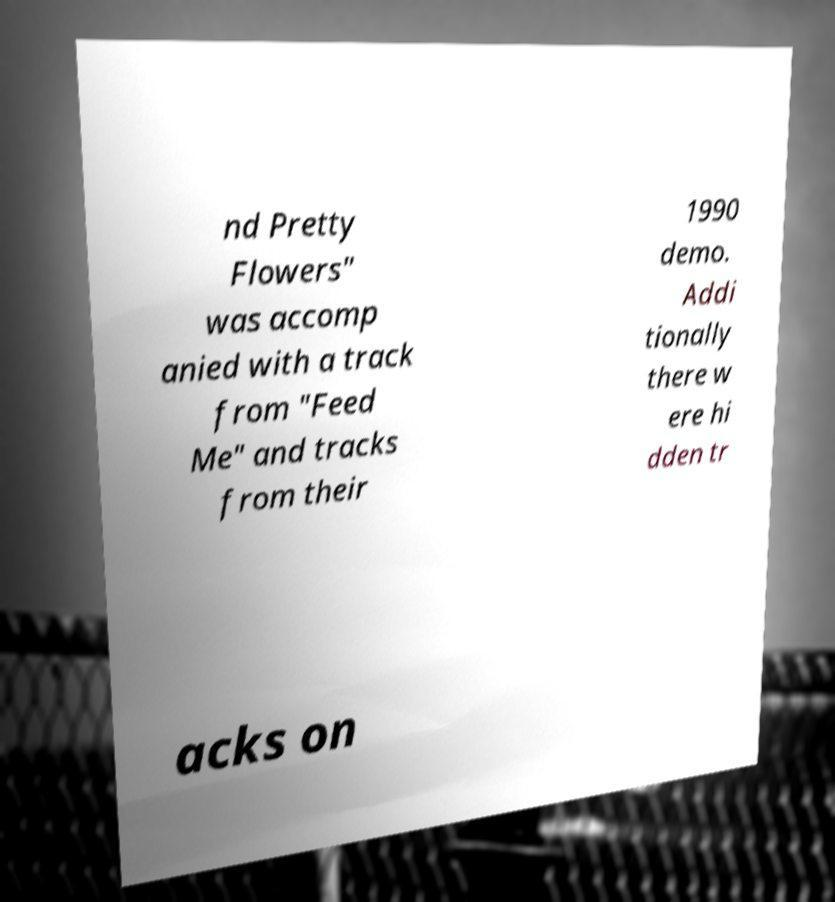Please read and relay the text visible in this image. What does it say? nd Pretty Flowers" was accomp anied with a track from "Feed Me" and tracks from their 1990 demo. Addi tionally there w ere hi dden tr acks on 